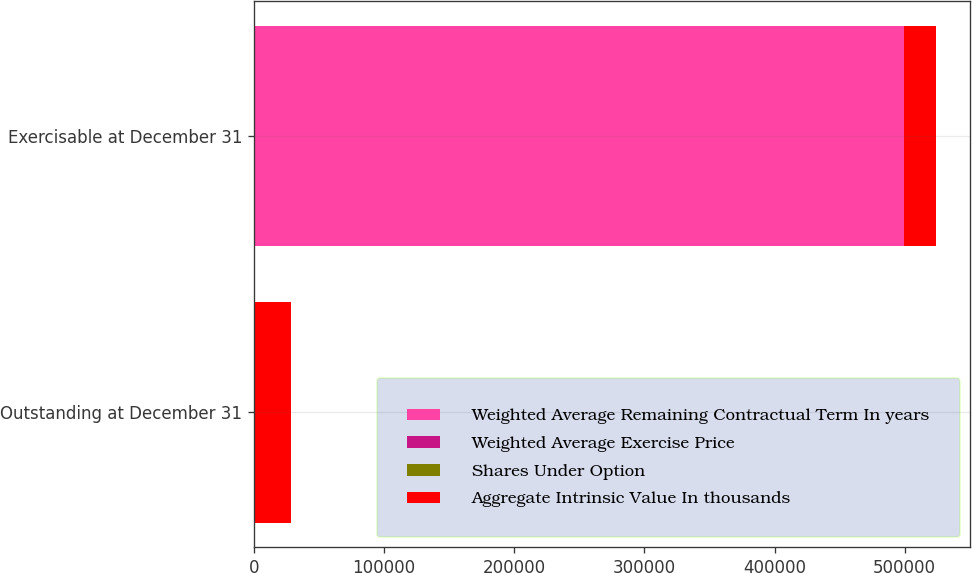Convert chart. <chart><loc_0><loc_0><loc_500><loc_500><stacked_bar_chart><ecel><fcel>Outstanding at December 31<fcel>Exercisable at December 31<nl><fcel>Weighted Average Remaining Contractual Term In years<fcel>49.13<fcel>499572<nl><fcel>Weighted Average Exercise Price<fcel>49.13<fcel>33.3<nl><fcel>Shares Under Option<fcel>5.8<fcel>4.1<nl><fcel>Aggregate Intrinsic Value In thousands<fcel>28654<fcel>24412<nl></chart> 